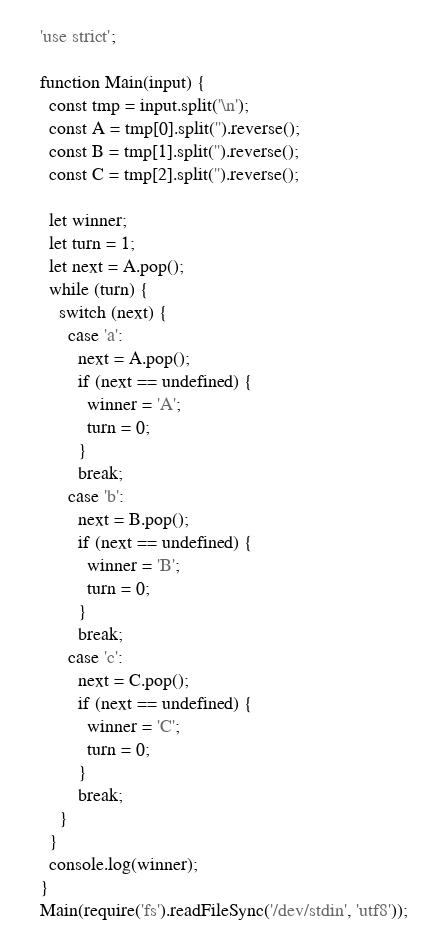Convert code to text. <code><loc_0><loc_0><loc_500><loc_500><_JavaScript_>'use strict';

function Main(input) {
  const tmp = input.split('\n');
  const A = tmp[0].split('').reverse();
  const B = tmp[1].split('').reverse();
  const C = tmp[2].split('').reverse();

  let winner;
  let turn = 1;
  let next = A.pop();
  while (turn) {
    switch (next) {
      case 'a':
        next = A.pop();
        if (next == undefined) {
          winner = 'A';
          turn = 0;
        }
        break;
      case 'b':
        next = B.pop();
        if (next == undefined) {
          winner = 'B';
          turn = 0;
        }
        break;
      case 'c':
        next = C.pop();
        if (next == undefined) {
          winner = 'C';
          turn = 0;
        }
        break;
    }
  }
  console.log(winner);
}
Main(require('fs').readFileSync('/dev/stdin', 'utf8'));
</code> 